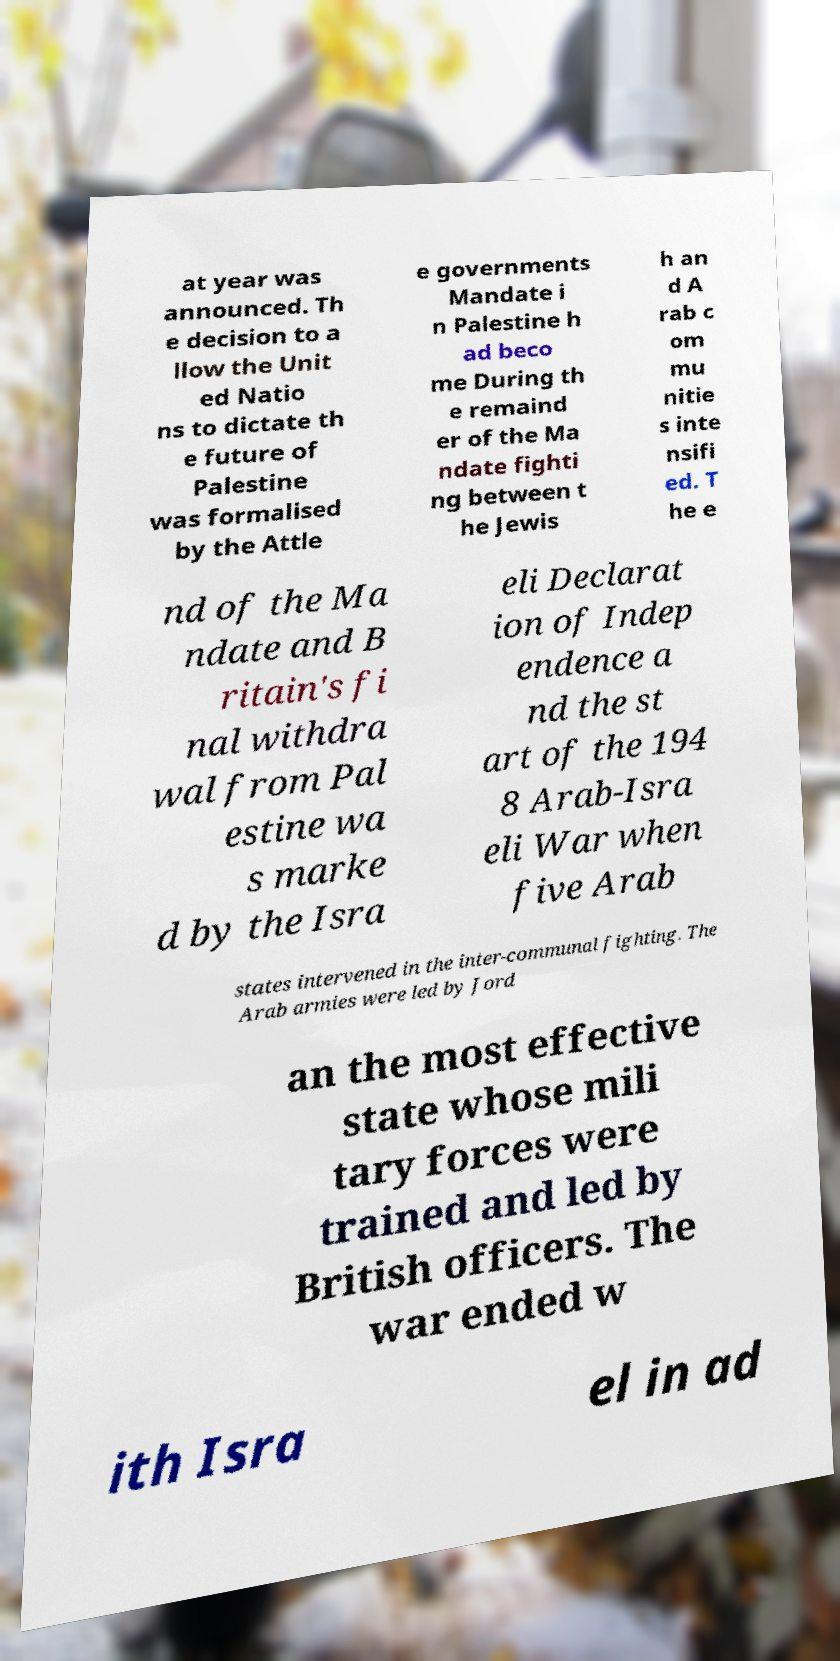Please identify and transcribe the text found in this image. at year was announced. Th e decision to a llow the Unit ed Natio ns to dictate th e future of Palestine was formalised by the Attle e governments Mandate i n Palestine h ad beco me During th e remaind er of the Ma ndate fighti ng between t he Jewis h an d A rab c om mu nitie s inte nsifi ed. T he e nd of the Ma ndate and B ritain's fi nal withdra wal from Pal estine wa s marke d by the Isra eli Declarat ion of Indep endence a nd the st art of the 194 8 Arab-Isra eli War when five Arab states intervened in the inter-communal fighting. The Arab armies were led by Jord an the most effective state whose mili tary forces were trained and led by British officers. The war ended w ith Isra el in ad 